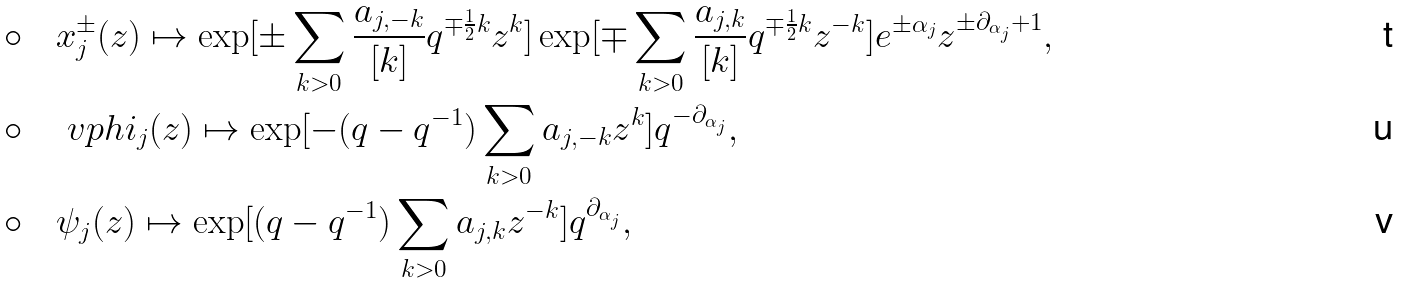Convert formula to latex. <formula><loc_0><loc_0><loc_500><loc_500>\circ & \quad x _ { j } ^ { \pm } ( z ) \mapsto \exp [ \pm \sum _ { k > 0 } \frac { a _ { j , - k } } { [ k ] } q ^ { \mp \frac { 1 } { 2 } k } z ^ { k } ] \exp [ \mp \sum _ { k > 0 } \frac { a _ { j , k } } { [ k ] } q ^ { \mp \frac { 1 } { 2 } k } z ^ { - k } ] e ^ { \pm \alpha _ { j } } z ^ { \pm \partial _ { \alpha _ { j } } + 1 } , \\ \circ & \quad \ v p h i _ { j } ( z ) \mapsto \exp [ - ( q - q ^ { - 1 } ) \sum _ { k > 0 } a _ { j , - k } z ^ { k } ] q ^ { - \partial _ { \alpha _ { j } } } , \\ \circ & \quad \psi _ { j } ( z ) \mapsto \exp [ ( q - q ^ { - 1 } ) \sum _ { k > 0 } a _ { j , k } z ^ { - k } ] q ^ { \partial _ { \alpha _ { j } } } ,</formula> 